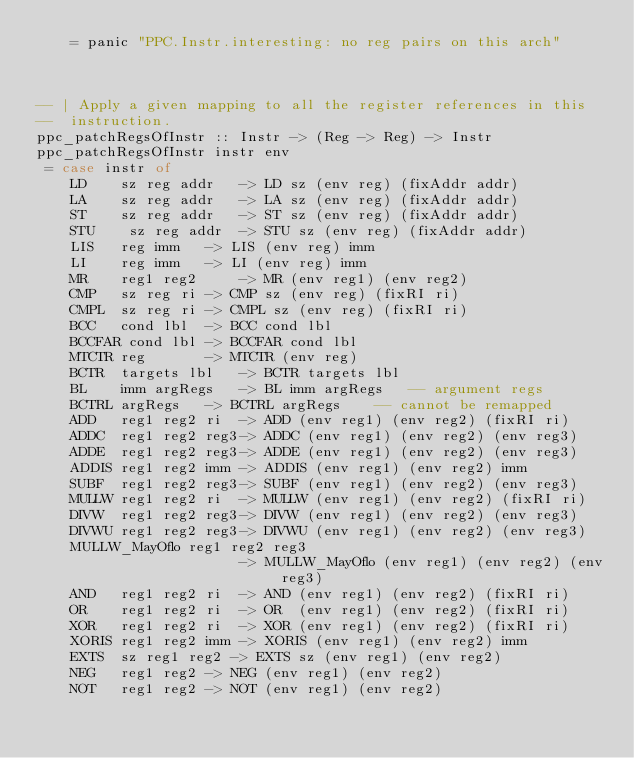<code> <loc_0><loc_0><loc_500><loc_500><_Haskell_>	= panic "PPC.Instr.interesting: no reg pairs on this arch"



-- | Apply a given mapping to all the register references in this
--	instruction.
ppc_patchRegsOfInstr :: Instr -> (Reg -> Reg) -> Instr
ppc_patchRegsOfInstr instr env 
 = case instr of
    LD    sz reg addr   -> LD sz (env reg) (fixAddr addr)
    LA    sz reg addr   -> LA sz (env reg) (fixAddr addr)
    ST    sz reg addr   -> ST sz (env reg) (fixAddr addr)
    STU    sz reg addr  -> STU sz (env reg) (fixAddr addr)
    LIS   reg imm	-> LIS (env reg) imm
    LI    reg imm	-> LI (env reg) imm
    MR	  reg1 reg2     -> MR (env reg1) (env reg2)
    CMP	  sz reg ri	-> CMP sz (env reg) (fixRI ri)
    CMPL  sz reg ri	-> CMPL sz (env reg) (fixRI ri)
    BCC	  cond lbl	-> BCC cond lbl
    BCCFAR cond lbl	-> BCCFAR cond lbl
    MTCTR reg		-> MTCTR (env reg)
    BCTR  targets lbl	-> BCTR targets lbl
    BL    imm argRegs	-> BL imm argRegs	-- argument regs
    BCTRL argRegs	-> BCTRL argRegs 	-- cannot be remapped
    ADD	  reg1 reg2 ri	-> ADD (env reg1) (env reg2) (fixRI ri)
    ADDC  reg1 reg2 reg3-> ADDC (env reg1) (env reg2) (env reg3)
    ADDE  reg1 reg2 reg3-> ADDE (env reg1) (env reg2) (env reg3)
    ADDIS reg1 reg2 imm -> ADDIS (env reg1) (env reg2) imm
    SUBF  reg1 reg2 reg3-> SUBF (env reg1) (env reg2) (env reg3)
    MULLW reg1 reg2 ri	-> MULLW (env reg1) (env reg2) (fixRI ri)
    DIVW  reg1 reg2 reg3-> DIVW (env reg1) (env reg2) (env reg3)
    DIVWU reg1 reg2 reg3-> DIVWU (env reg1) (env reg2) (env reg3)
    MULLW_MayOflo reg1 reg2 reg3
                        -> MULLW_MayOflo (env reg1) (env reg2) (env reg3)
    AND	  reg1 reg2 ri	-> AND (env reg1) (env reg2) (fixRI ri)
    OR 	  reg1 reg2 ri	-> OR  (env reg1) (env reg2) (fixRI ri)
    XOR	  reg1 reg2 ri	-> XOR (env reg1) (env reg2) (fixRI ri)
    XORIS reg1 reg2 imm -> XORIS (env reg1) (env reg2) imm
    EXTS  sz reg1 reg2 -> EXTS sz (env reg1) (env reg2)
    NEG	  reg1 reg2	-> NEG (env reg1) (env reg2)
    NOT	  reg1 reg2	-> NOT (env reg1) (env reg2)</code> 